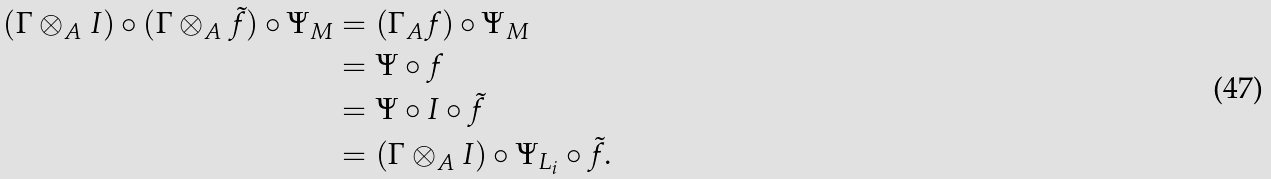<formula> <loc_0><loc_0><loc_500><loc_500>( \Gamma \otimes _ { A } I ) \circ ( \Gamma \otimes _ { A } \tilde { f } ) \circ \Psi _ { M } & = ( \Gamma _ { A } f ) \circ \Psi _ { M } \\ & = \Psi \circ f \\ & = \Psi \circ I \circ \tilde { f } \\ & = ( \Gamma \otimes _ { A } I ) \circ \Psi _ { L _ { i } } \circ \tilde { f } .</formula> 